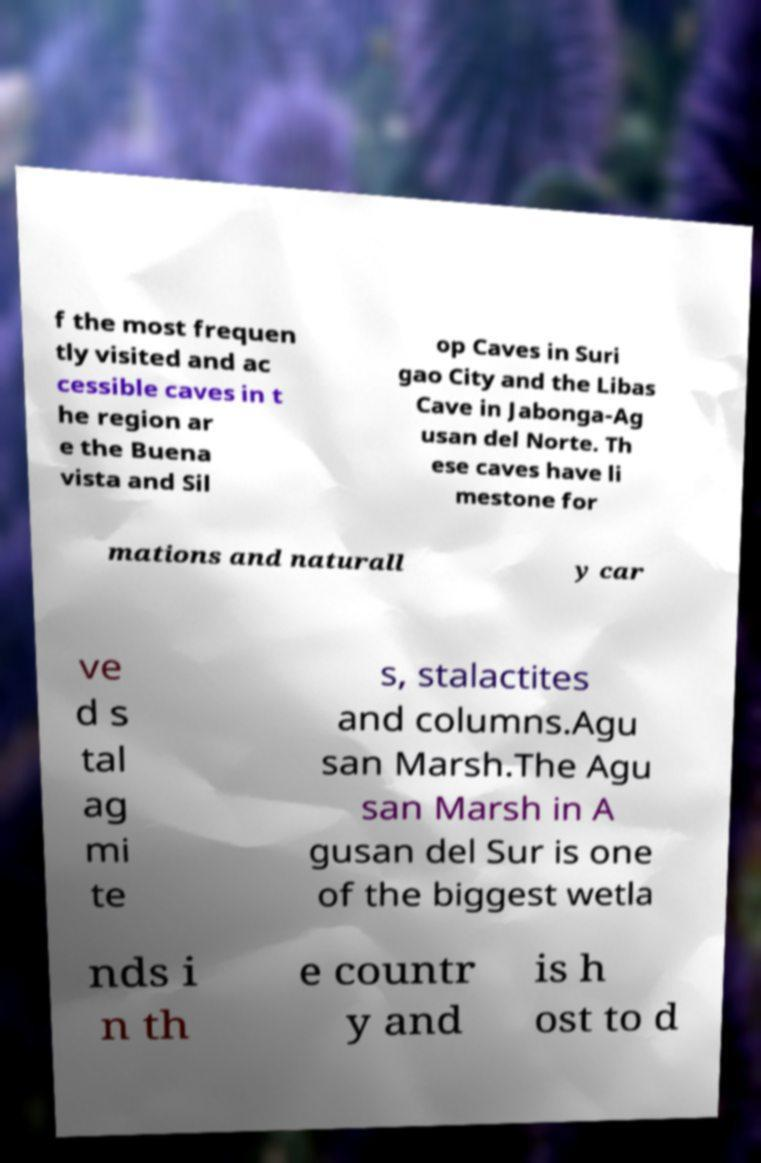Please identify and transcribe the text found in this image. f the most frequen tly visited and ac cessible caves in t he region ar e the Buena vista and Sil op Caves in Suri gao City and the Libas Cave in Jabonga-Ag usan del Norte. Th ese caves have li mestone for mations and naturall y car ve d s tal ag mi te s, stalactites and columns.Agu san Marsh.The Agu san Marsh in A gusan del Sur is one of the biggest wetla nds i n th e countr y and is h ost to d 